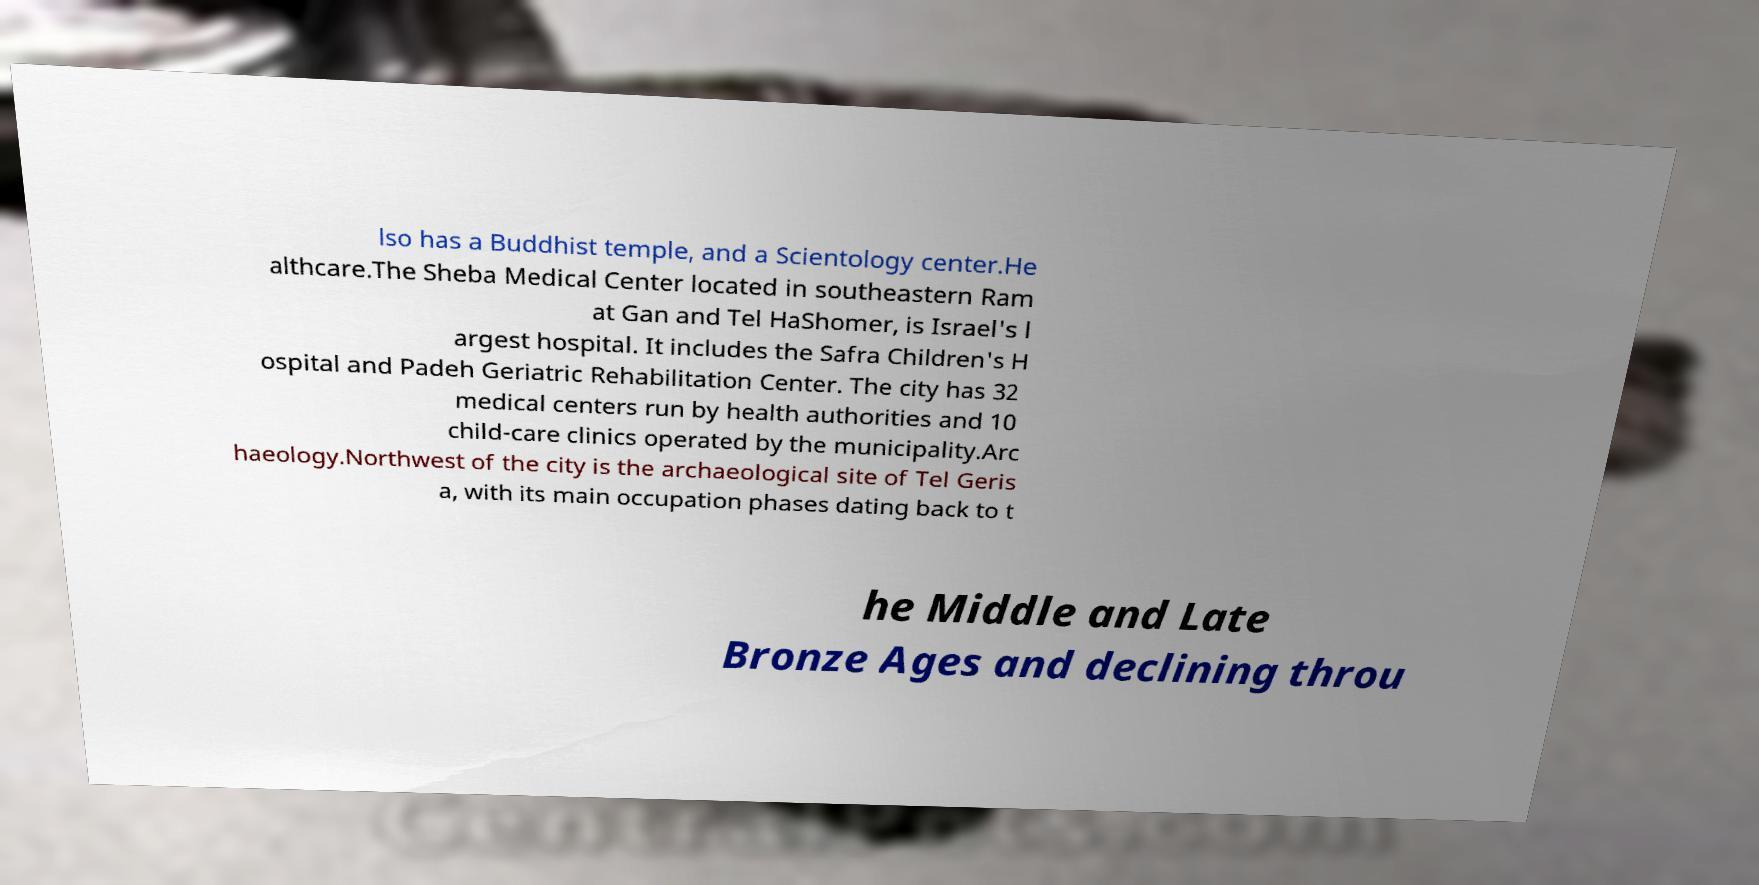Could you extract and type out the text from this image? lso has a Buddhist temple, and a Scientology center.He althcare.The Sheba Medical Center located in southeastern Ram at Gan and Tel HaShomer, is Israel's l argest hospital. It includes the Safra Children's H ospital and Padeh Geriatric Rehabilitation Center. The city has 32 medical centers run by health authorities and 10 child-care clinics operated by the municipality.Arc haeology.Northwest of the city is the archaeological site of Tel Geris a, with its main occupation phases dating back to t he Middle and Late Bronze Ages and declining throu 